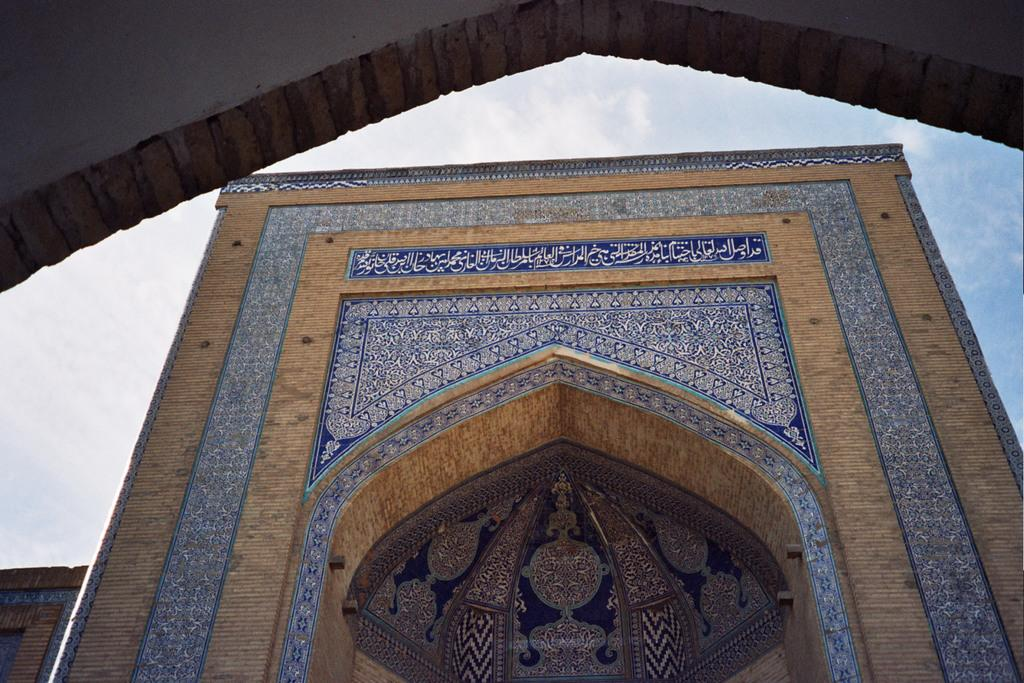What type of structure is visible in the image? There is a building in the image. What can be seen in the background of the image? The sky is visible in the image. What is the condition of the sky in the image? Clouds are present in the sky. What type of mist can be seen surrounding the building in the image? There is no mist present in the image; only the building and clouds in the sky are visible. 